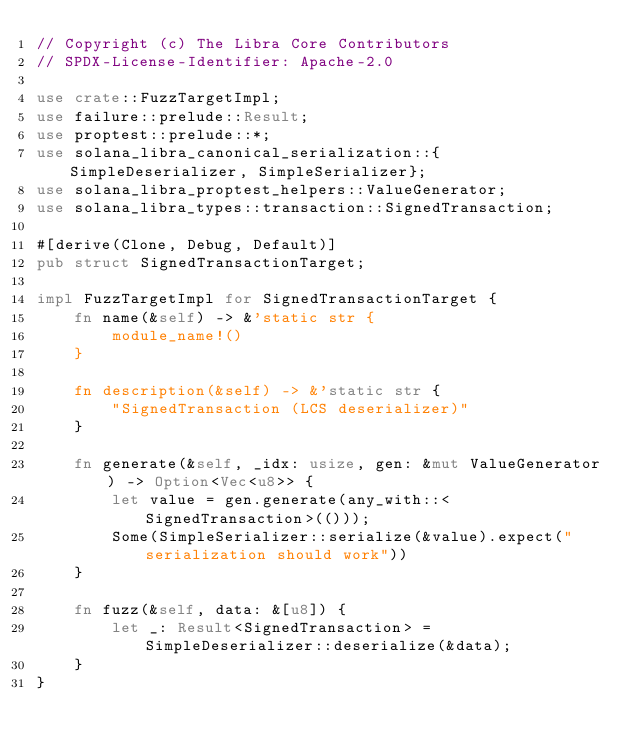Convert code to text. <code><loc_0><loc_0><loc_500><loc_500><_Rust_>// Copyright (c) The Libra Core Contributors
// SPDX-License-Identifier: Apache-2.0

use crate::FuzzTargetImpl;
use failure::prelude::Result;
use proptest::prelude::*;
use solana_libra_canonical_serialization::{SimpleDeserializer, SimpleSerializer};
use solana_libra_proptest_helpers::ValueGenerator;
use solana_libra_types::transaction::SignedTransaction;

#[derive(Clone, Debug, Default)]
pub struct SignedTransactionTarget;

impl FuzzTargetImpl for SignedTransactionTarget {
    fn name(&self) -> &'static str {
        module_name!()
    }

    fn description(&self) -> &'static str {
        "SignedTransaction (LCS deserializer)"
    }

    fn generate(&self, _idx: usize, gen: &mut ValueGenerator) -> Option<Vec<u8>> {
        let value = gen.generate(any_with::<SignedTransaction>(()));
        Some(SimpleSerializer::serialize(&value).expect("serialization should work"))
    }

    fn fuzz(&self, data: &[u8]) {
        let _: Result<SignedTransaction> = SimpleDeserializer::deserialize(&data);
    }
}
</code> 